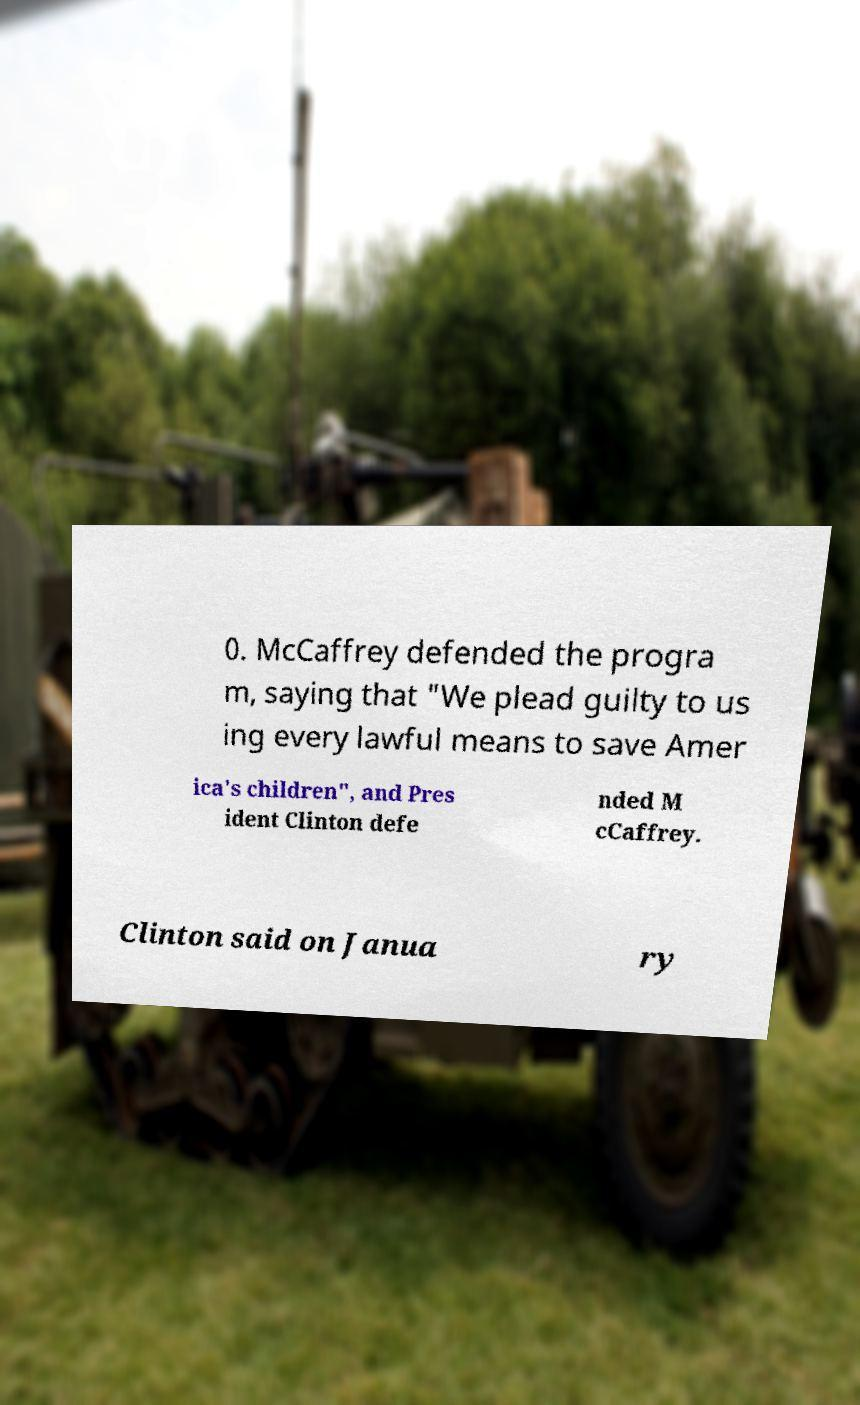What messages or text are displayed in this image? I need them in a readable, typed format. 0. McCaffrey defended the progra m, saying that "We plead guilty to us ing every lawful means to save Amer ica's children", and Pres ident Clinton defe nded M cCaffrey. Clinton said on Janua ry 